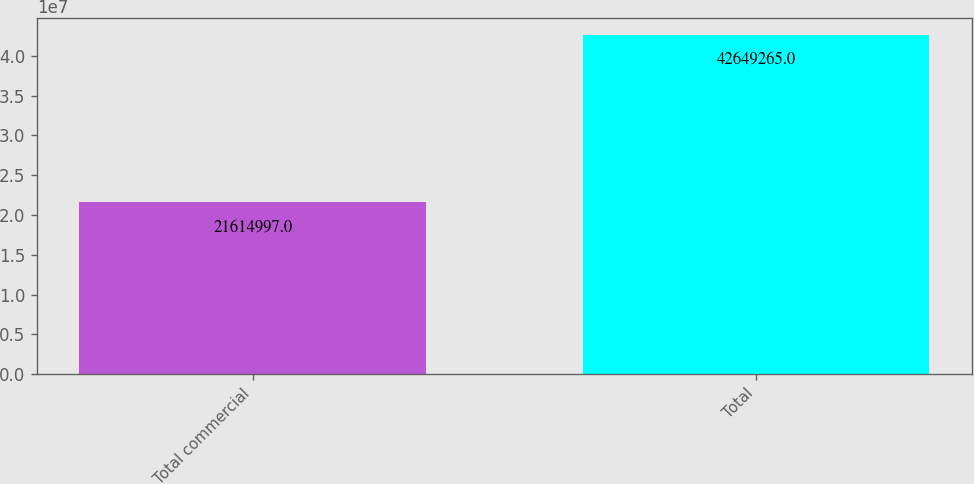<chart> <loc_0><loc_0><loc_500><loc_500><bar_chart><fcel>Total commercial<fcel>Total<nl><fcel>2.1615e+07<fcel>4.26493e+07<nl></chart> 